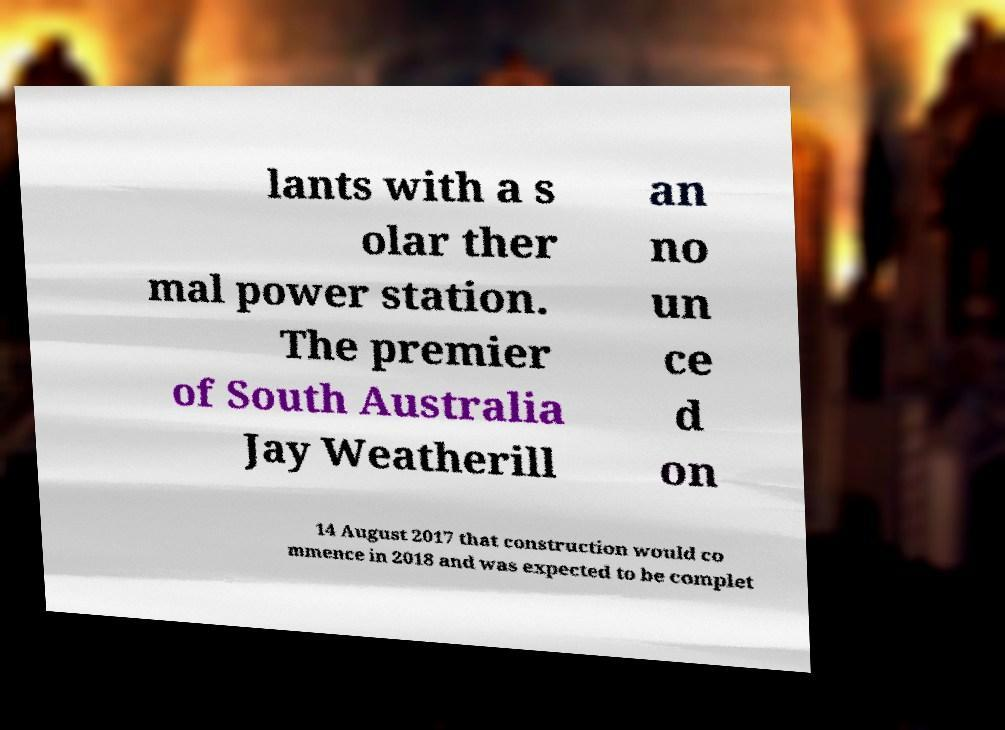Please read and relay the text visible in this image. What does it say? lants with a s olar ther mal power station. The premier of South Australia Jay Weatherill an no un ce d on 14 August 2017 that construction would co mmence in 2018 and was expected to be complet 